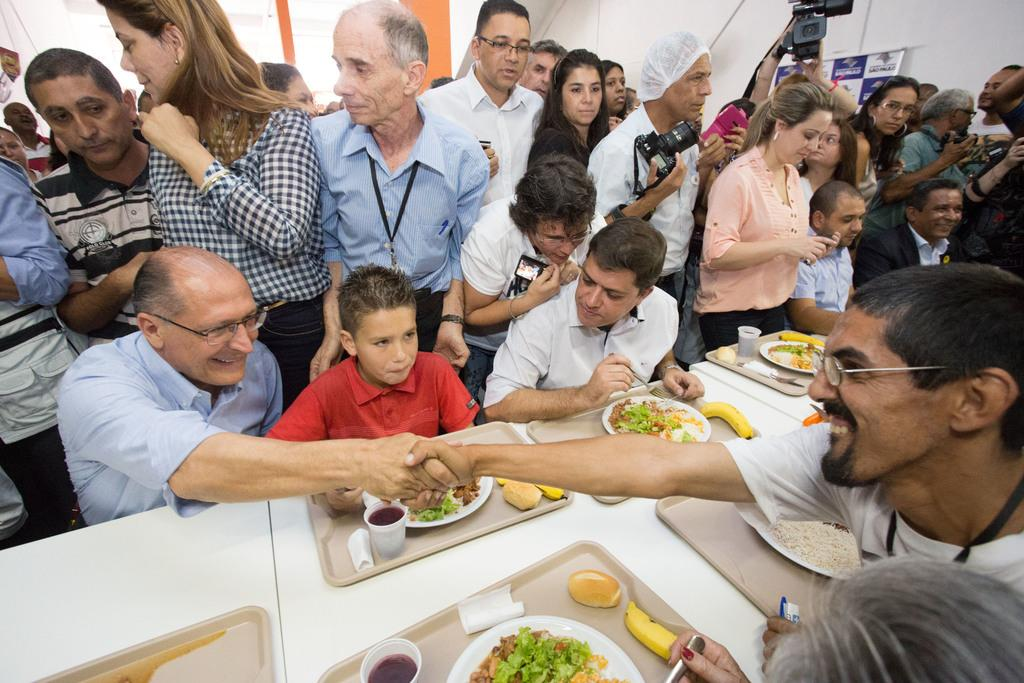How many people are in the image? There is a group of people in the image. What objects are on the table in the image? There is a tray, a plate, food, a glass, a spoon, and a banana on the table in the image. Can you describe the table setting in the image? The table setting includes a tray, a plate, food, a glass, a spoon, and a banana. Is there any indication of photography in the image? Yes, there is a camera visible at the back side of the image. What type of pollution is visible in the image? There is no pollution visible in the image; it features a group of people and a table setting. What type of education is being provided in the image? There is no indication of education in the image; it focuses on a group of people and a table setting. 